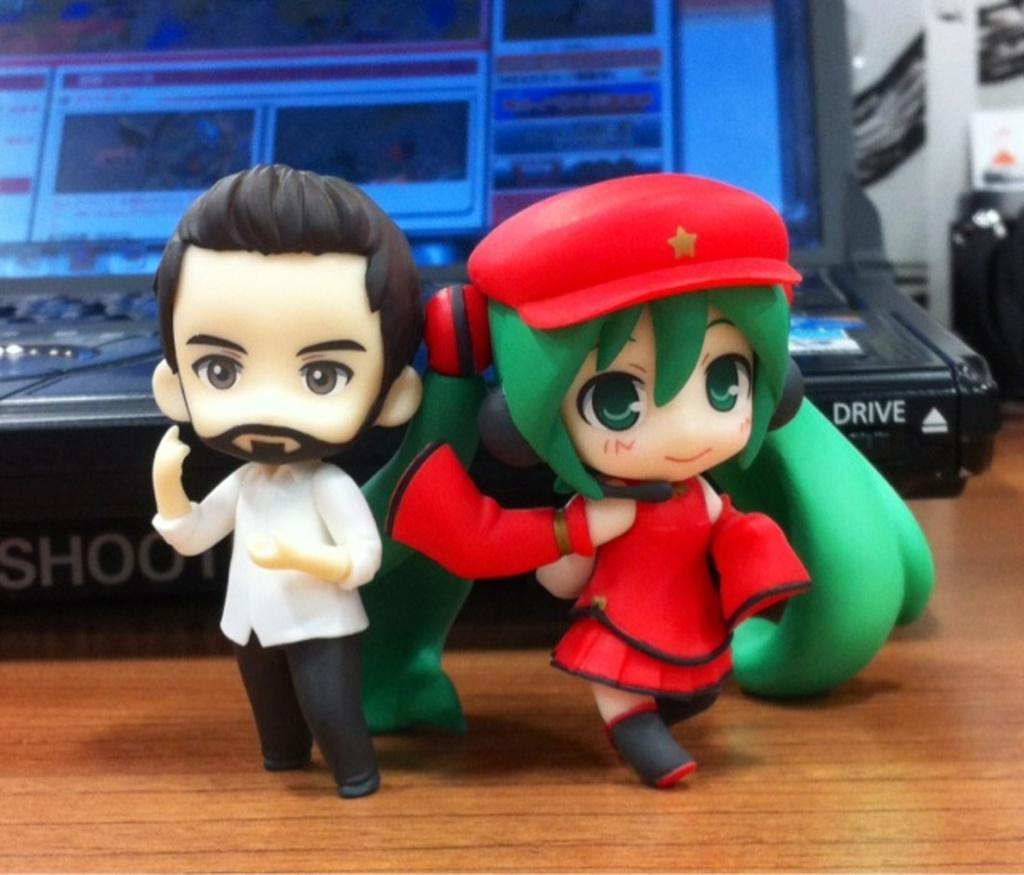Describe this image in one or two sentences. There are toys on the wooden surface. In the back there is an electronic device. 